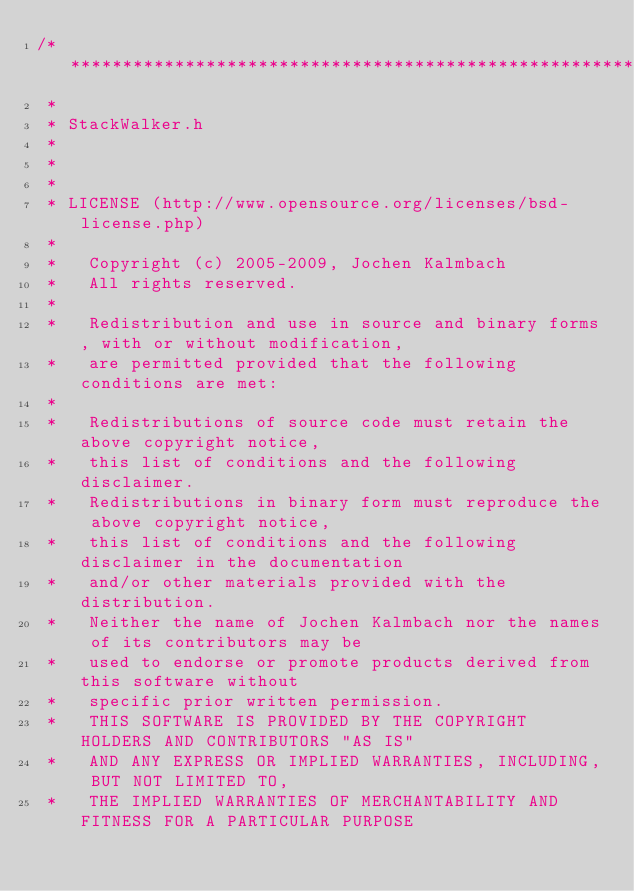<code> <loc_0><loc_0><loc_500><loc_500><_C_>/**********************************************************************
 * 
 * StackWalker.h
 *
 *
 *
 * LICENSE (http://www.opensource.org/licenses/bsd-license.php)
 *
 *   Copyright (c) 2005-2009, Jochen Kalmbach
 *   All rights reserved.
 *
 *   Redistribution and use in source and binary forms, with or without modification, 
 *   are permitted provided that the following conditions are met:
 *
 *   Redistributions of source code must retain the above copyright notice, 
 *   this list of conditions and the following disclaimer. 
 *   Redistributions in binary form must reproduce the above copyright notice, 
 *   this list of conditions and the following disclaimer in the documentation 
 *   and/or other materials provided with the distribution. 
 *   Neither the name of Jochen Kalmbach nor the names of its contributors may be 
 *   used to endorse or promote products derived from this software without 
 *   specific prior written permission. 
 *   THIS SOFTWARE IS PROVIDED BY THE COPYRIGHT HOLDERS AND CONTRIBUTORS "AS IS" 
 *   AND ANY EXPRESS OR IMPLIED WARRANTIES, INCLUDING, BUT NOT LIMITED TO, 
 *   THE IMPLIED WARRANTIES OF MERCHANTABILITY AND FITNESS FOR A PARTICULAR PURPOSE </code> 